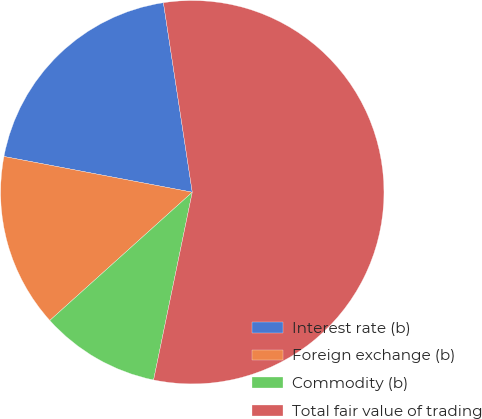Convert chart to OTSL. <chart><loc_0><loc_0><loc_500><loc_500><pie_chart><fcel>Interest rate (b)<fcel>Foreign exchange (b)<fcel>Commodity (b)<fcel>Total fair value of trading<nl><fcel>19.61%<fcel>14.65%<fcel>10.1%<fcel>55.64%<nl></chart> 